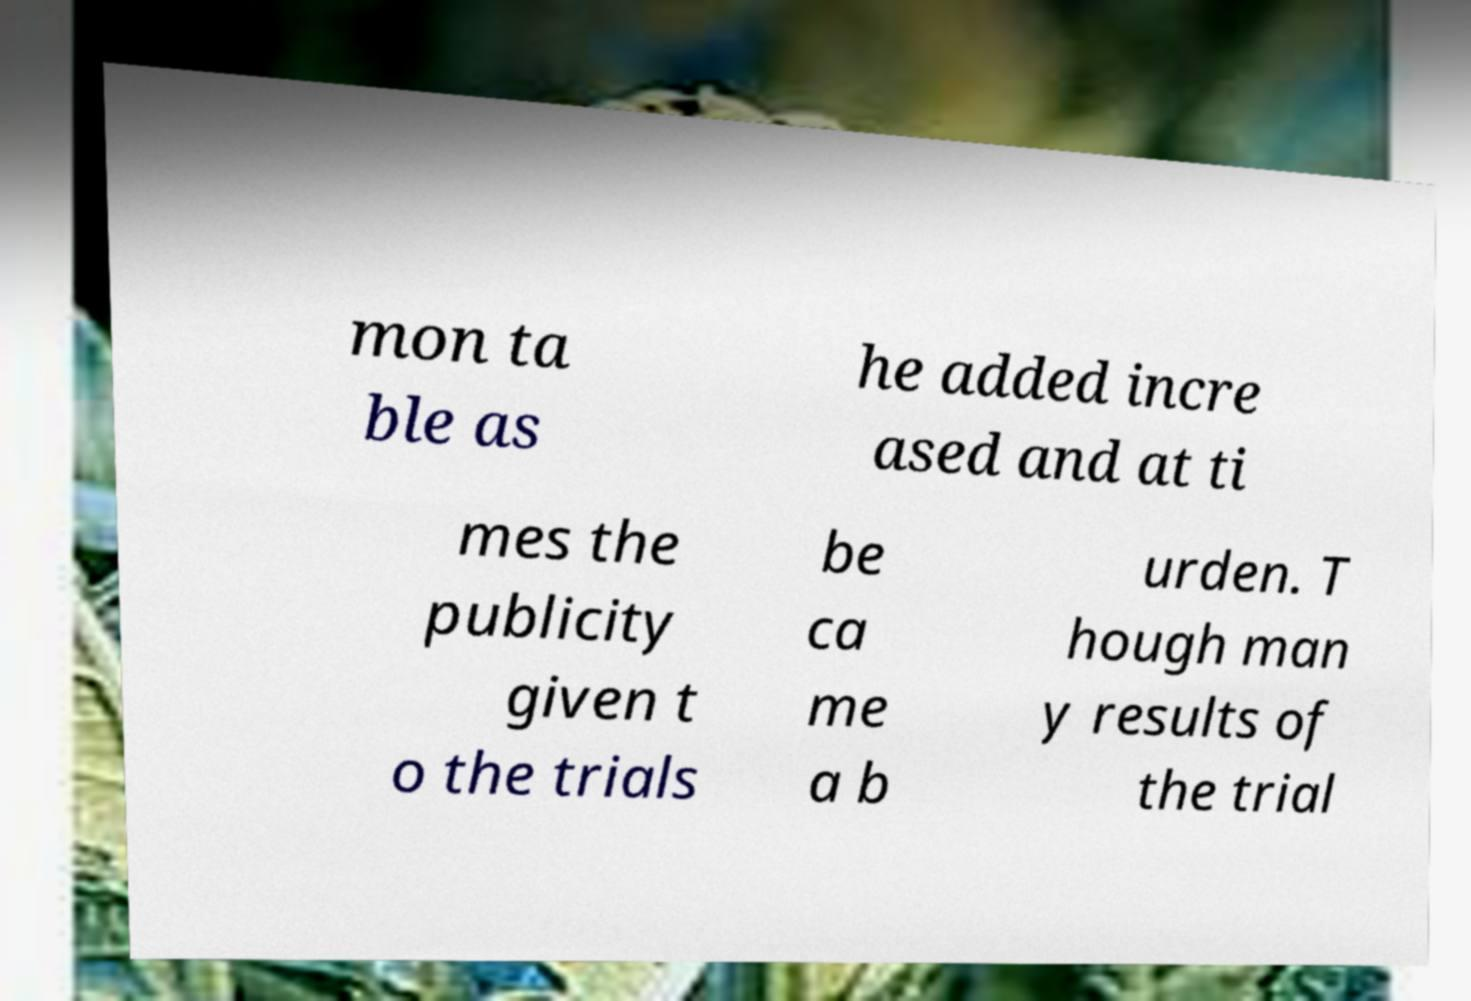Please read and relay the text visible in this image. What does it say? mon ta ble as he added incre ased and at ti mes the publicity given t o the trials be ca me a b urden. T hough man y results of the trial 